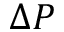<formula> <loc_0><loc_0><loc_500><loc_500>\Delta P</formula> 